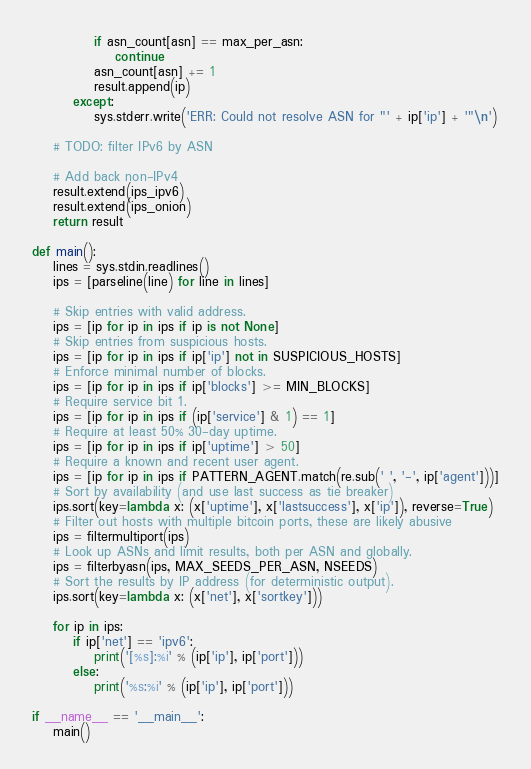Convert code to text. <code><loc_0><loc_0><loc_500><loc_500><_Python_>            if asn_count[asn] == max_per_asn:
                continue
            asn_count[asn] += 1
            result.append(ip)
        except:
            sys.stderr.write('ERR: Could not resolve ASN for "' + ip['ip'] + '"\n')

    # TODO: filter IPv6 by ASN

    # Add back non-IPv4
    result.extend(ips_ipv6)
    result.extend(ips_onion)
    return result

def main():
    lines = sys.stdin.readlines()
    ips = [parseline(line) for line in lines]

    # Skip entries with valid address.
    ips = [ip for ip in ips if ip is not None]
    # Skip entries from suspicious hosts.
    ips = [ip for ip in ips if ip['ip'] not in SUSPICIOUS_HOSTS]
    # Enforce minimal number of blocks.
    ips = [ip for ip in ips if ip['blocks'] >= MIN_BLOCKS]
    # Require service bit 1.
    ips = [ip for ip in ips if (ip['service'] & 1) == 1]
    # Require at least 50% 30-day uptime.
    ips = [ip for ip in ips if ip['uptime'] > 50]
    # Require a known and recent user agent.
    ips = [ip for ip in ips if PATTERN_AGENT.match(re.sub(' ', '-', ip['agent']))]
    # Sort by availability (and use last success as tie breaker)
    ips.sort(key=lambda x: (x['uptime'], x['lastsuccess'], x['ip']), reverse=True)
    # Filter out hosts with multiple bitcoin ports, these are likely abusive
    ips = filtermultiport(ips)
    # Look up ASNs and limit results, both per ASN and globally.
    ips = filterbyasn(ips, MAX_SEEDS_PER_ASN, NSEEDS)
    # Sort the results by IP address (for deterministic output).
    ips.sort(key=lambda x: (x['net'], x['sortkey']))

    for ip in ips:
        if ip['net'] == 'ipv6':
            print('[%s]:%i' % (ip['ip'], ip['port']))
        else:
            print('%s:%i' % (ip['ip'], ip['port']))

if __name__ == '__main__':
    main()
</code> 